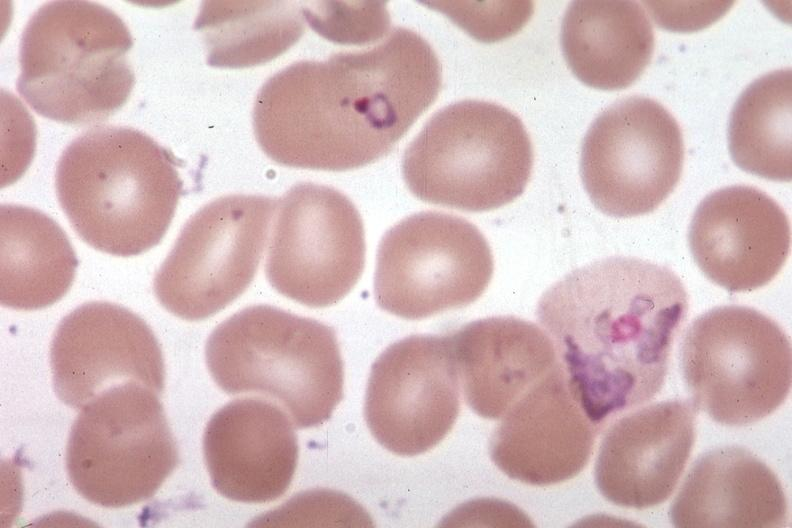what is present?
Answer the question using a single word or phrase. Hematologic 